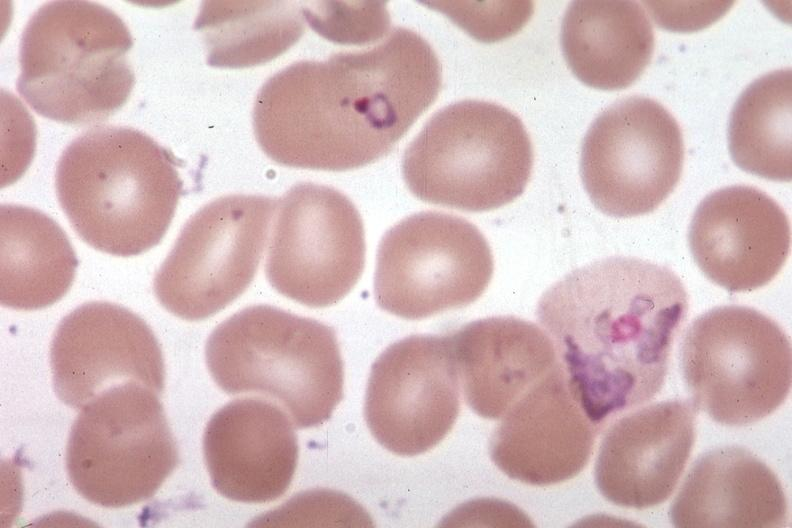what is present?
Answer the question using a single word or phrase. Hematologic 